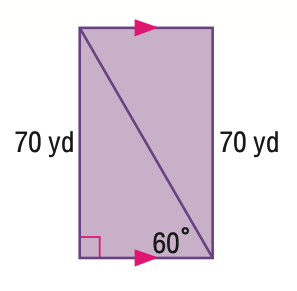Question: Find the area of the quadrilateral.
Choices:
A. 2450
B. 2829.0
C. 3464.8
D. 4900
Answer with the letter. Answer: B 